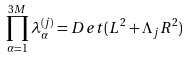Convert formula to latex. <formula><loc_0><loc_0><loc_500><loc_500>\prod _ { \alpha = 1 } ^ { 3 M } \lambda ^ { ( j ) } _ { \alpha } = D e t ( L ^ { 2 } + \Lambda _ { j } R ^ { 2 } )</formula> 